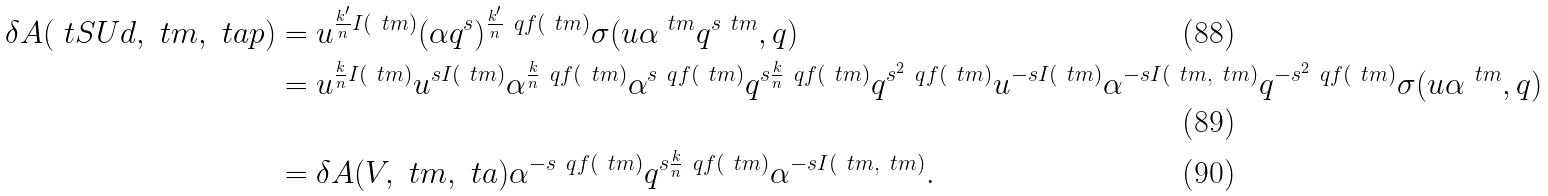Convert formula to latex. <formula><loc_0><loc_0><loc_500><loc_500>\delta A ( \ t S U d , \ t m , \ t a p ) & = u ^ { \frac { k ^ { \prime } } { n } I ( \ t m ) } ( \alpha q ^ { s } ) ^ { \frac { k ^ { \prime } } { n } \ q f ( \ t m ) } \sigma ( u \alpha ^ { \ t m } q ^ { s \ t m } , q ) \\ & = u ^ { \frac { k } { n } I ( \ t m ) } u ^ { s I ( \ t m ) } \alpha ^ { \frac { k } { n } \ q f ( \ t m ) } \alpha ^ { s \ q f ( \ t m ) } q ^ { s \frac { k } { n } \ q f ( \ t m ) } q ^ { s ^ { 2 } \ q f ( \ t m ) } u ^ { - s I ( \ t m ) } \alpha ^ { - s I ( \ t m , \ t m ) } q ^ { - s ^ { 2 } \ q f ( \ t m ) } \sigma ( u \alpha ^ { \ t m } , q ) \\ & = \delta A ( V , \ t m , \ t a ) \alpha ^ { - s \ q f ( \ t m ) } q ^ { s \frac { k } { n } \ q f ( \ t m ) } \alpha ^ { - s I ( \ t m , \ t m ) } .</formula> 